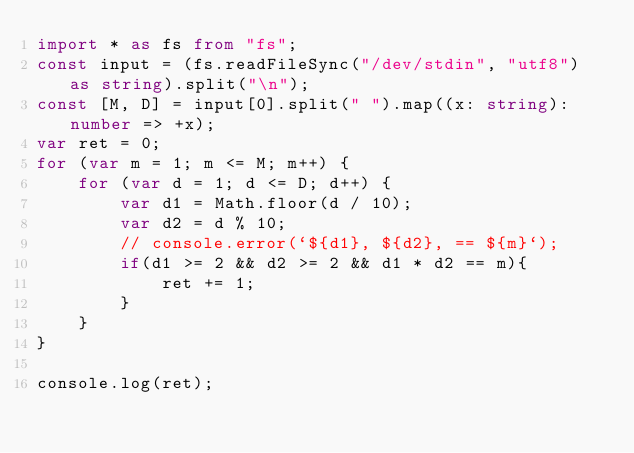Convert code to text. <code><loc_0><loc_0><loc_500><loc_500><_TypeScript_>import * as fs from "fs";
const input = (fs.readFileSync("/dev/stdin", "utf8") as string).split("\n");
const [M, D] = input[0].split(" ").map((x: string): number => +x);
var ret = 0;
for (var m = 1; m <= M; m++) {
    for (var d = 1; d <= D; d++) {
        var d1 = Math.floor(d / 10);
        var d2 = d % 10;
        // console.error(`${d1}, ${d2}, == ${m}`);
        if(d1 >= 2 && d2 >= 2 && d1 * d2 == m){
            ret += 1;
        }
    }
}

console.log(ret);</code> 